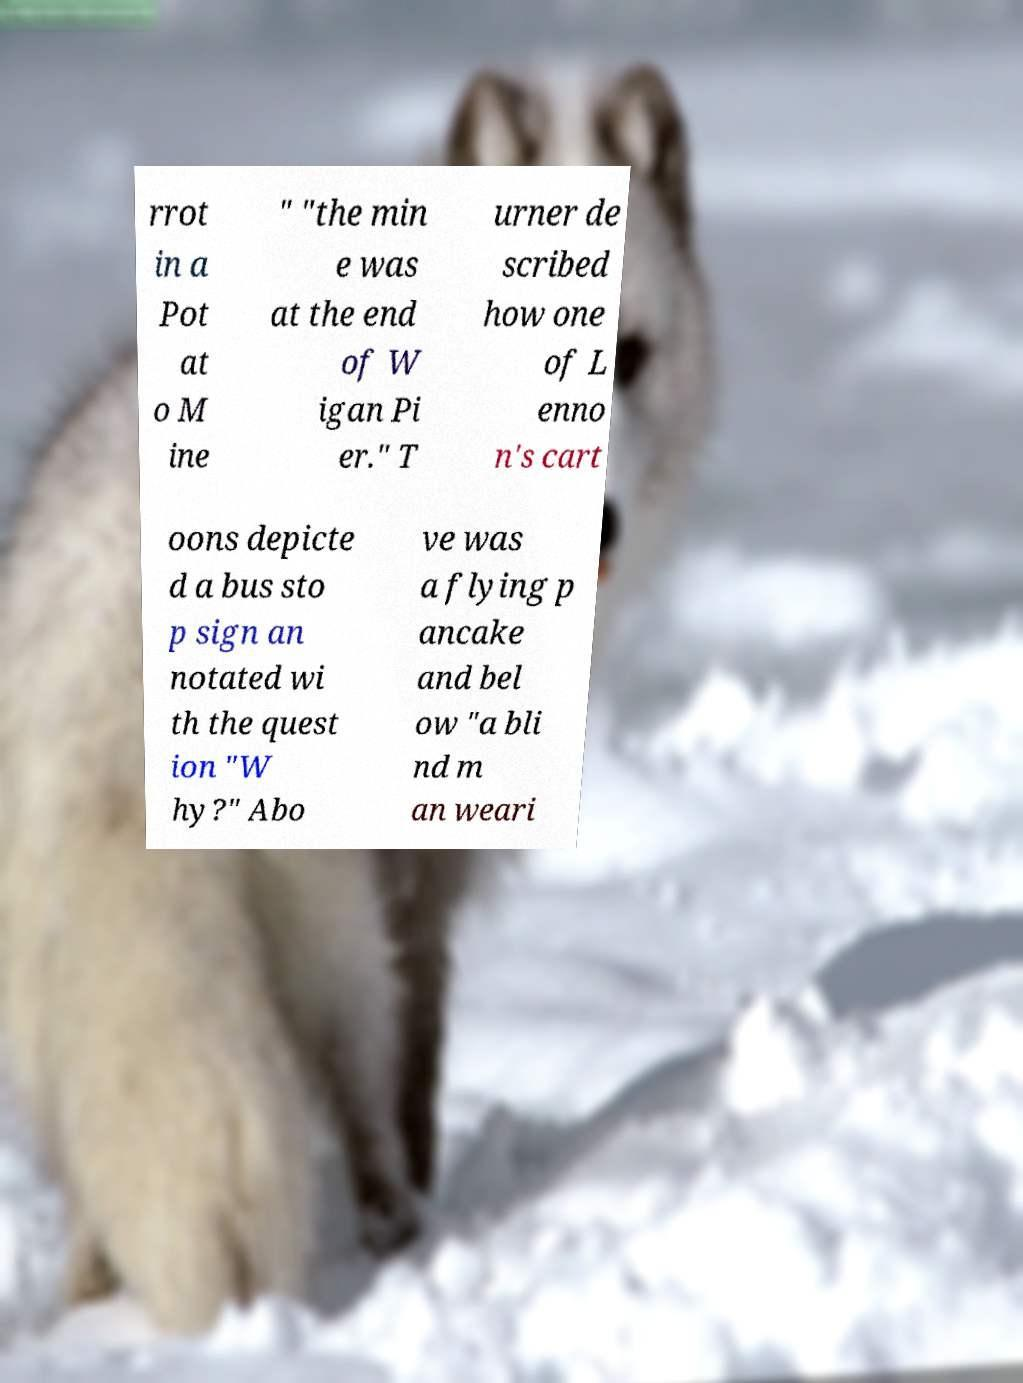There's text embedded in this image that I need extracted. Can you transcribe it verbatim? rrot in a Pot at o M ine " "the min e was at the end of W igan Pi er." T urner de scribed how one of L enno n's cart oons depicte d a bus sto p sign an notated wi th the quest ion "W hy?" Abo ve was a flying p ancake and bel ow "a bli nd m an weari 